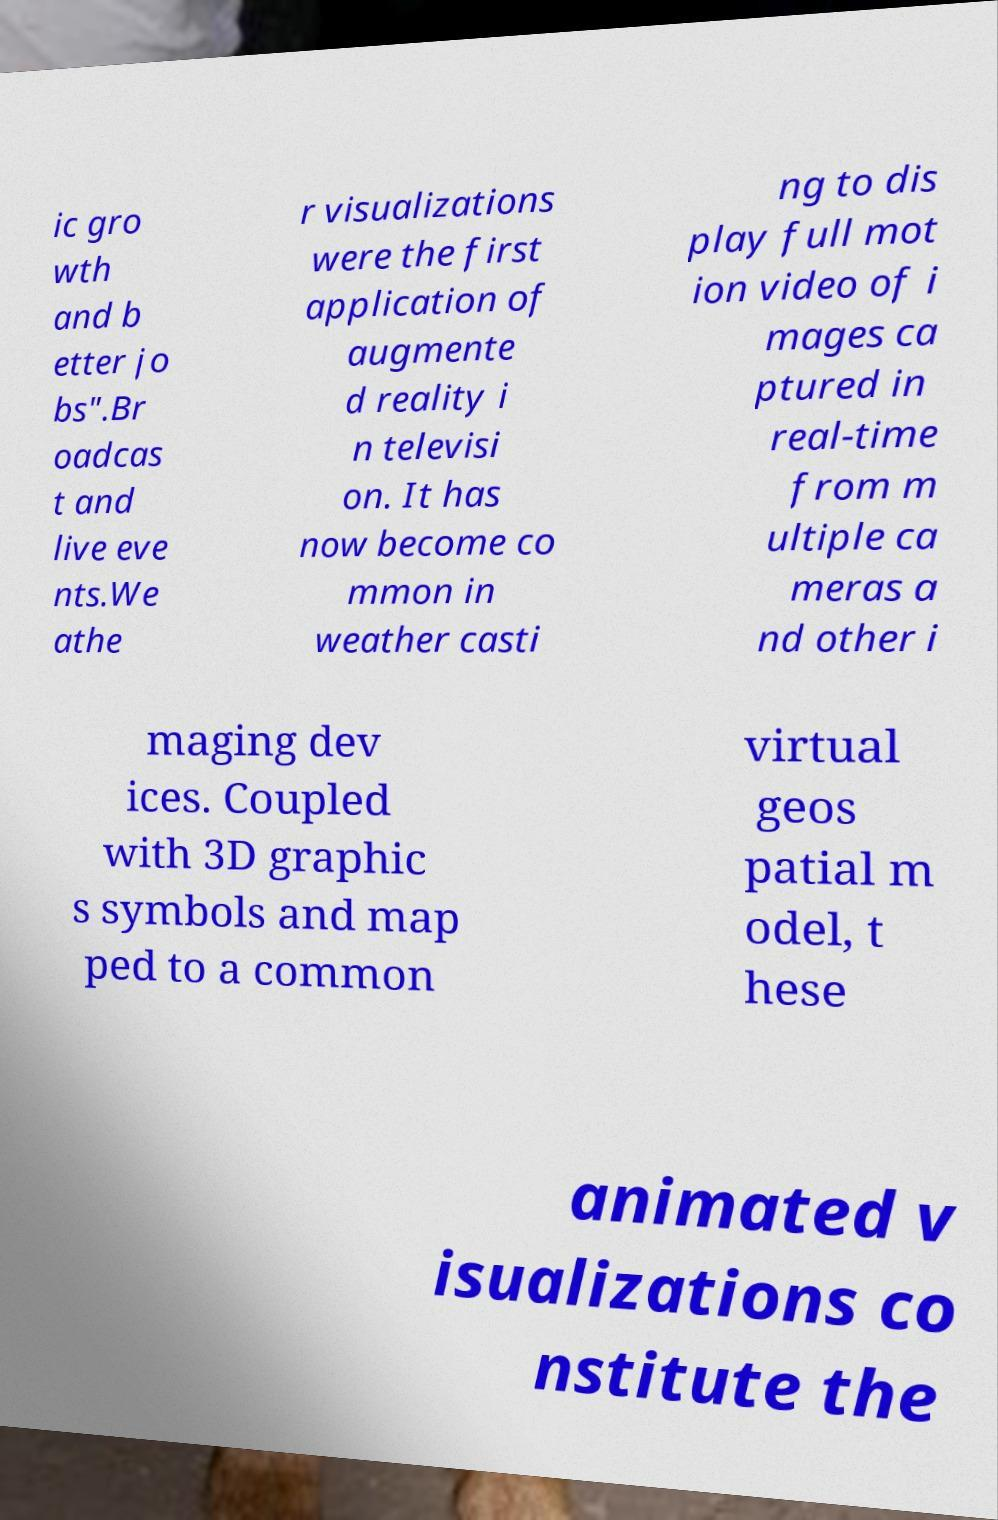I need the written content from this picture converted into text. Can you do that? ic gro wth and b etter jo bs".Br oadcas t and live eve nts.We athe r visualizations were the first application of augmente d reality i n televisi on. It has now become co mmon in weather casti ng to dis play full mot ion video of i mages ca ptured in real-time from m ultiple ca meras a nd other i maging dev ices. Coupled with 3D graphic s symbols and map ped to a common virtual geos patial m odel, t hese animated v isualizations co nstitute the 